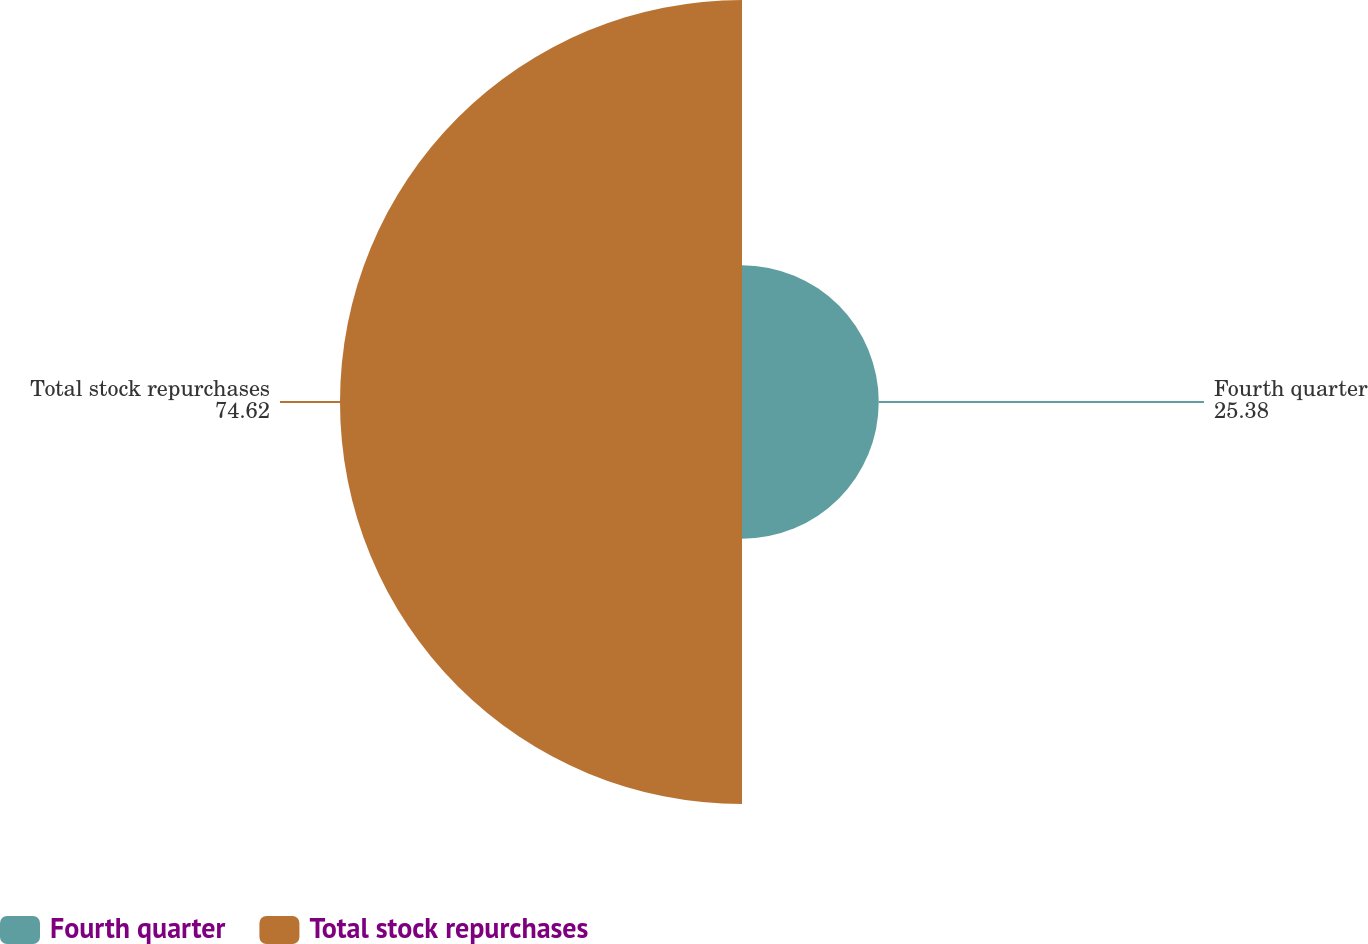<chart> <loc_0><loc_0><loc_500><loc_500><pie_chart><fcel>Fourth quarter<fcel>Total stock repurchases<nl><fcel>25.38%<fcel>74.62%<nl></chart> 